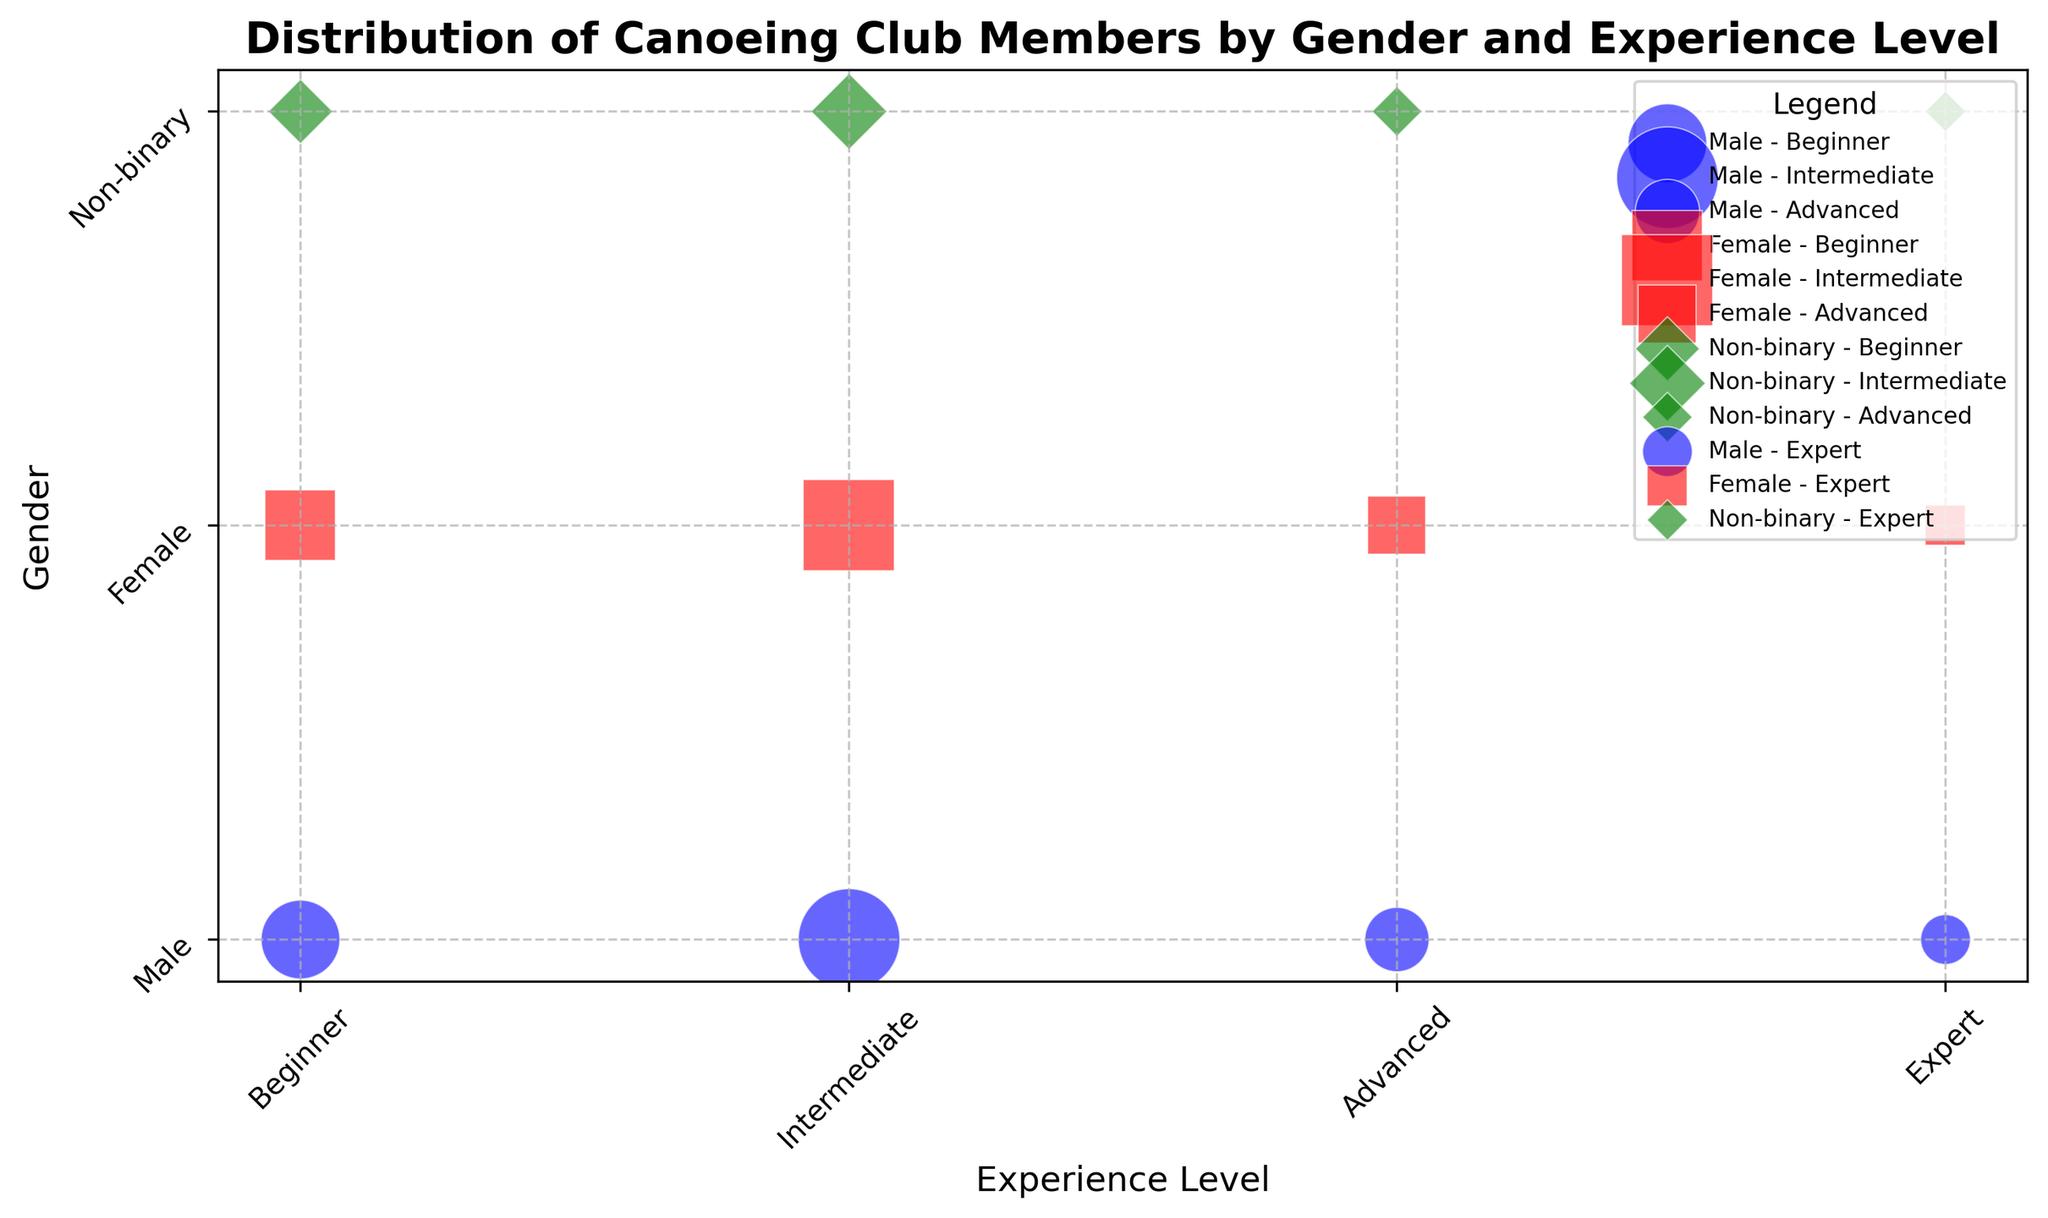What is the total number of male canoeing club members? The figure shows the counts of male members for each experience level. To find the total, sum up all the counts: Beginner (15) + Intermediate (25) + Advanced (10) + Expert (6). So, the total is 15 + 25 + 10 + 6 = 56.
Answer: 56 Which gender has the highest number of members at the Intermediate level? From the figure, compare the number of members at the Intermediate level for each gender. Males have 25, females have 20, and non-binary individuals have 7. The highest count is for males with 25.
Answer: Male Are there more female advanced members than non-binary intermediate members? Check the counts for female advanced members and non-binary intermediate members from the figure. Female advanced members are 8, and non-binary intermediate members are 7. Since 8 > 7, there are more female advanced members.
Answer: Yes What is the difference in the number of beginner-level members between males and females? From the figure, note the number of beginner-level members: Males have 15 and females have 12. The difference is 15 - 12 = 3.
Answer: 3 Which gender has the smallest bubble for the Expert level? The size of the bubble indicates the number of members. Compare the bubbles for the Expert level: Males have 6, females have 4, and non-binary individuals have 2. The smallest bubble is for non-binary individuals with 2 members.
Answer: Non-binary What is the average number of canoeing club members at the Advanced level across all genders? To calculate the average, sum the counts of advanced-level members for all genders and divide by the number of genders: Males (10) + Females (8) + Non-binary (3). Total is 10 + 8 + 3 = 21. There are 3 genders, so the average is 21 / 3 = 7.
Answer: 7 Which experience level and gender combination has the largest bubble? The largest bubble represents the highest count. From the figure, the highest count is for males at the Intermediate level with 25 members.
Answer: Male - Intermediate What is the total count of members at the Expert level across all genders? Add the counts for the Expert level across all genders: Male (6) + Female (4) + Non-binary (2). Total is 6 + 4 + 2 = 12.
Answer: 12 How many more male members are there at the Intermediate level than at the Expert level? Determine the counts for male members at the Intermediate (25) and Expert (6) levels and calculate the difference: 25 - 6 = 19.
Answer: 19 